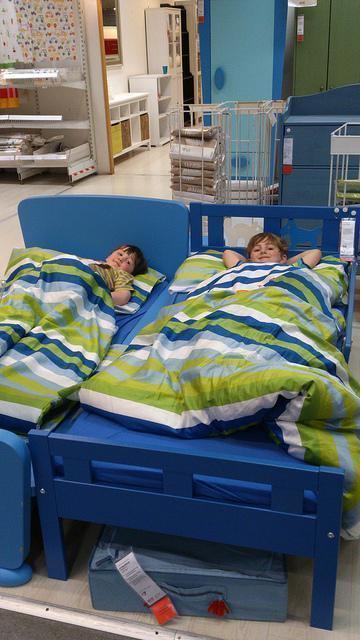Where are the beds that the boys are lying on?
Indicate the correct response and explain using: 'Answer: answer
Rationale: rationale.'
Options: Living room, bedroom, daycare, furniture store. Answer: furniture store.
Rationale: Looks like they are in a store that sells bedding. 